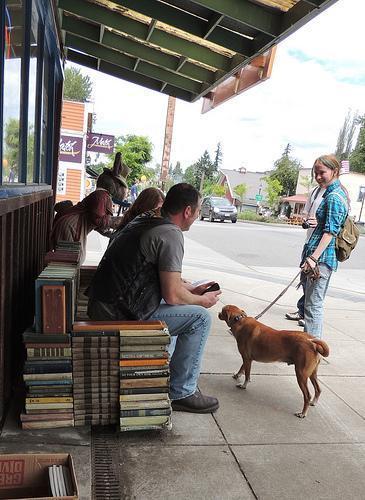How many cars can be seen on the street?
Give a very brief answer. 1. 